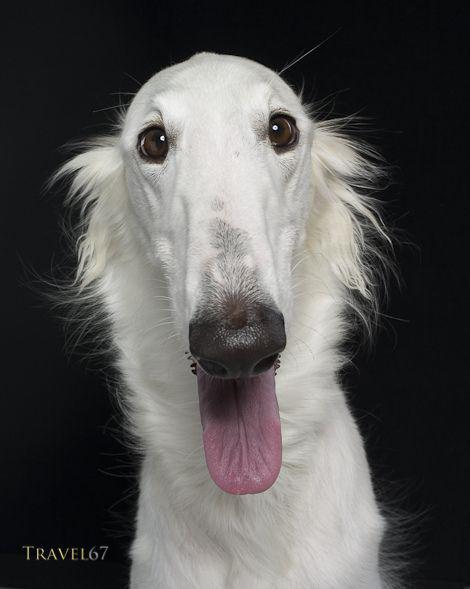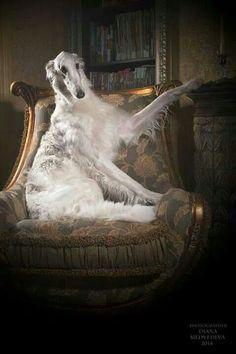The first image is the image on the left, the second image is the image on the right. Examine the images to the left and right. Is the description "A dog is in a chair." accurate? Answer yes or no. Yes. The first image is the image on the left, the second image is the image on the right. For the images displayed, is the sentence "The right image shows a hound posed on an upholstered chair, with one front paw propped on the side of the chair." factually correct? Answer yes or no. Yes. 